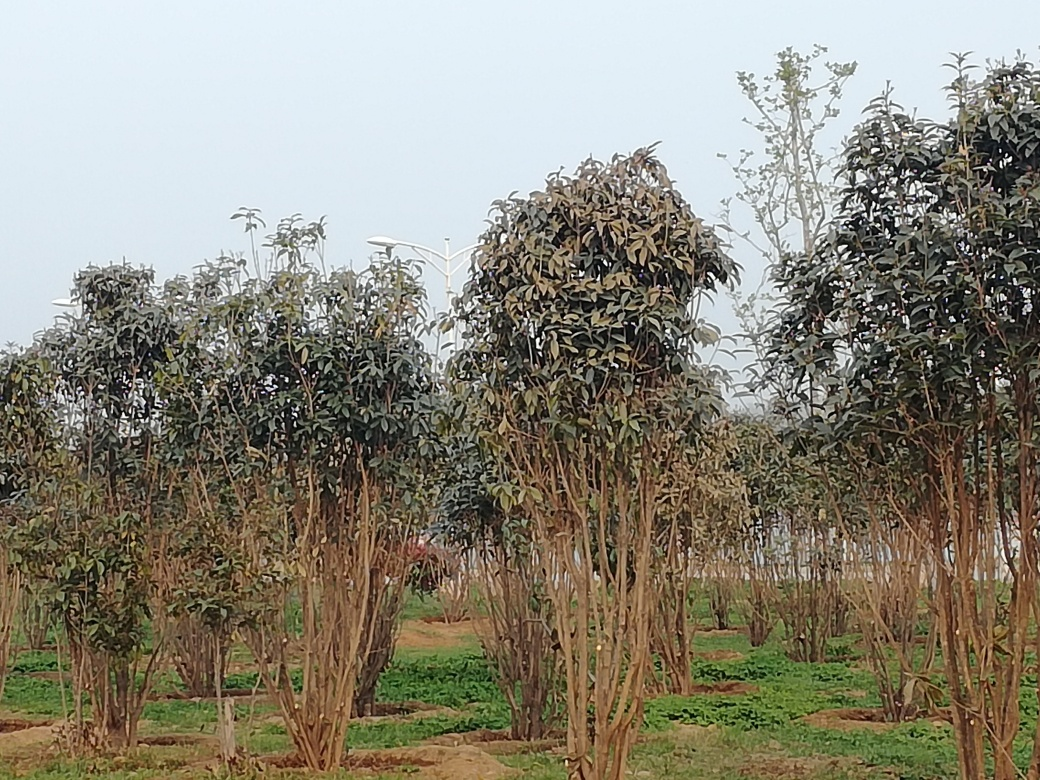Can this image tell us anything about the local climate or ecosystem? The image suggests a temperate climate where deciduous trees grow. The overcast sky and lack of underbrush may hint at seasonal changes or recent agricultural management, which could be part of a larger ecosystem or farming approach in this region. 